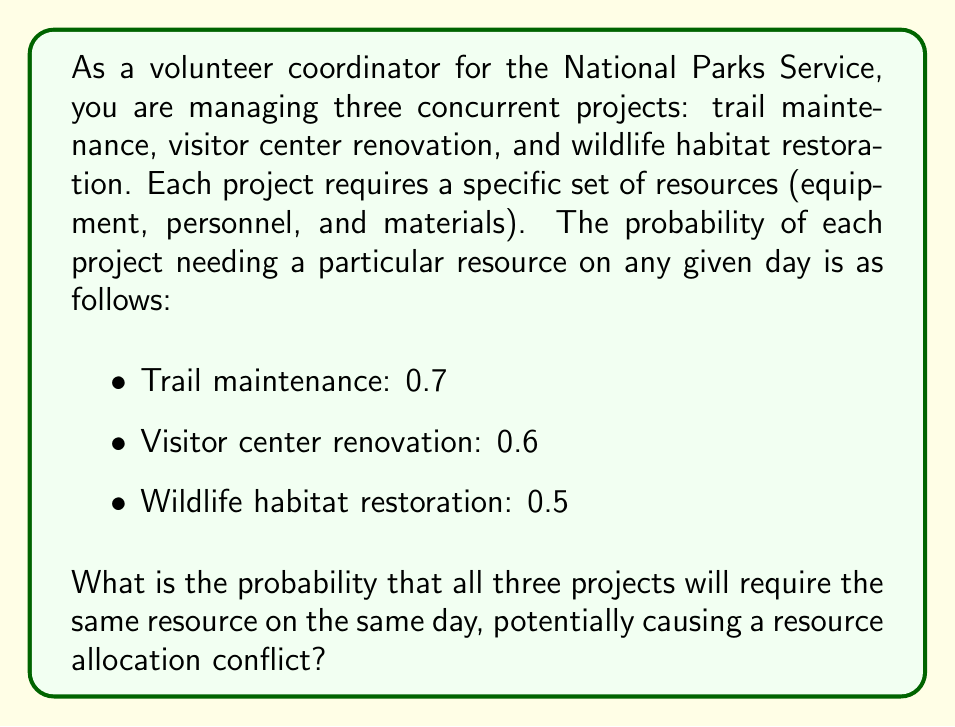Teach me how to tackle this problem. To solve this problem, we need to use the concept of independent events and multiply their individual probabilities.

1. Let's define our events:
   - Event A: Trail maintenance needs the resource (P(A) = 0.7)
   - Event B: Visitor center renovation needs the resource (P(B) = 0.6)
   - Event C: Wildlife habitat restoration needs the resource (P(C) = 0.5)

2. We want to find the probability of all three events occurring simultaneously. Since these events are independent (the resource needs of one project don't affect the others), we can multiply their individual probabilities:

   $$P(A \cap B \cap C) = P(A) \times P(B) \times P(C)$$

3. Substituting the given probabilities:

   $$P(A \cap B \cap C) = 0.7 \times 0.6 \times 0.5$$

4. Calculating the result:

   $$P(A \cap B \cap C) = 0.21$$

Therefore, the probability that all three projects will require the same resource on the same day is 0.21 or 21%.
Answer: The probability that all three projects will require the same resource on the same day, potentially causing a resource allocation conflict, is 0.21 or 21%. 